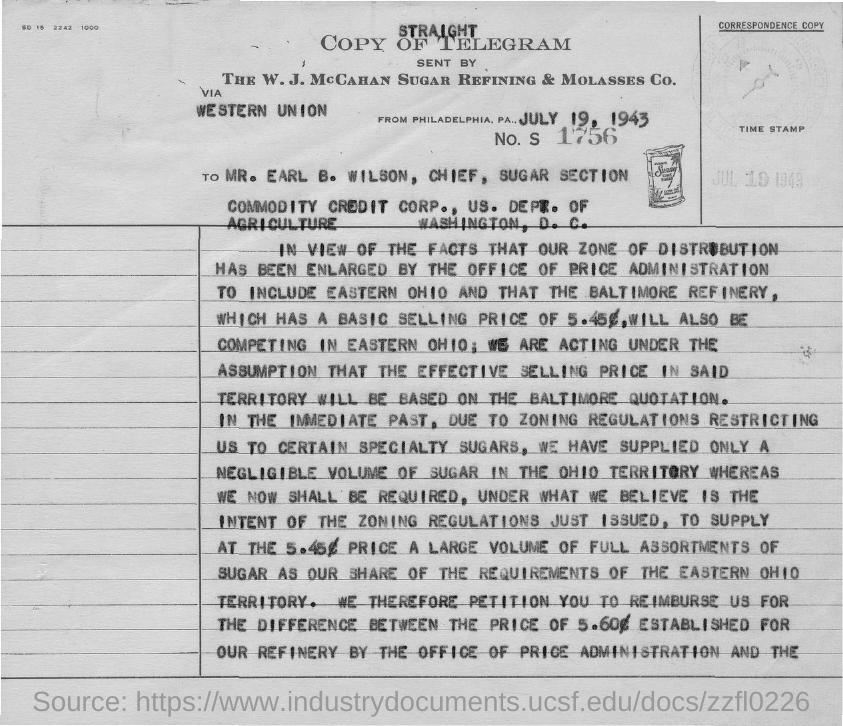Mention a couple of crucial points in this snapshot. The date mentioned in the document is July 19, 1943. The number mentioned in the document is 1756.. 